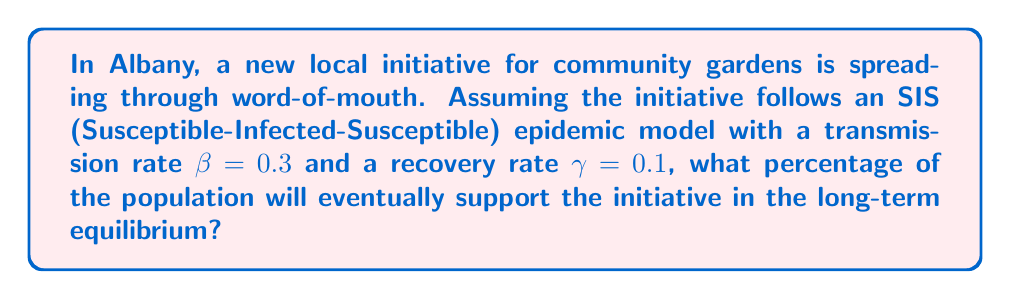Help me with this question. To solve this problem, we'll use the SIS model and find the equilibrium point:

1) In the SIS model, the population is divided into two compartments:
   S: Susceptible (those who haven't adopted the initiative)
   I: Infected (those who have adopted the initiative)

2) The basic reproduction number $R_0$ is given by:
   $$R_0 = \frac{\beta}{\gamma}$$

3) Substituting the given values:
   $$R_0 = \frac{0.3}{0.1} = 3$$

4) In the SIS model, if $R_0 > 1$, the disease (or in this case, the initiative) will persist in the population. The equilibrium proportion of infected individuals (I*) is given by:
   $$I^* = 1 - \frac{1}{R_0}$$

5) Substituting our calculated $R_0$:
   $$I^* = 1 - \frac{1}{3} = \frac{2}{3}$$

6) Convert to a percentage:
   $$\frac{2}{3} \times 100\% = 66.67\%$$

Therefore, in the long-term equilibrium, approximately 66.67% of the population will support the community garden initiative.
Answer: 66.67% 